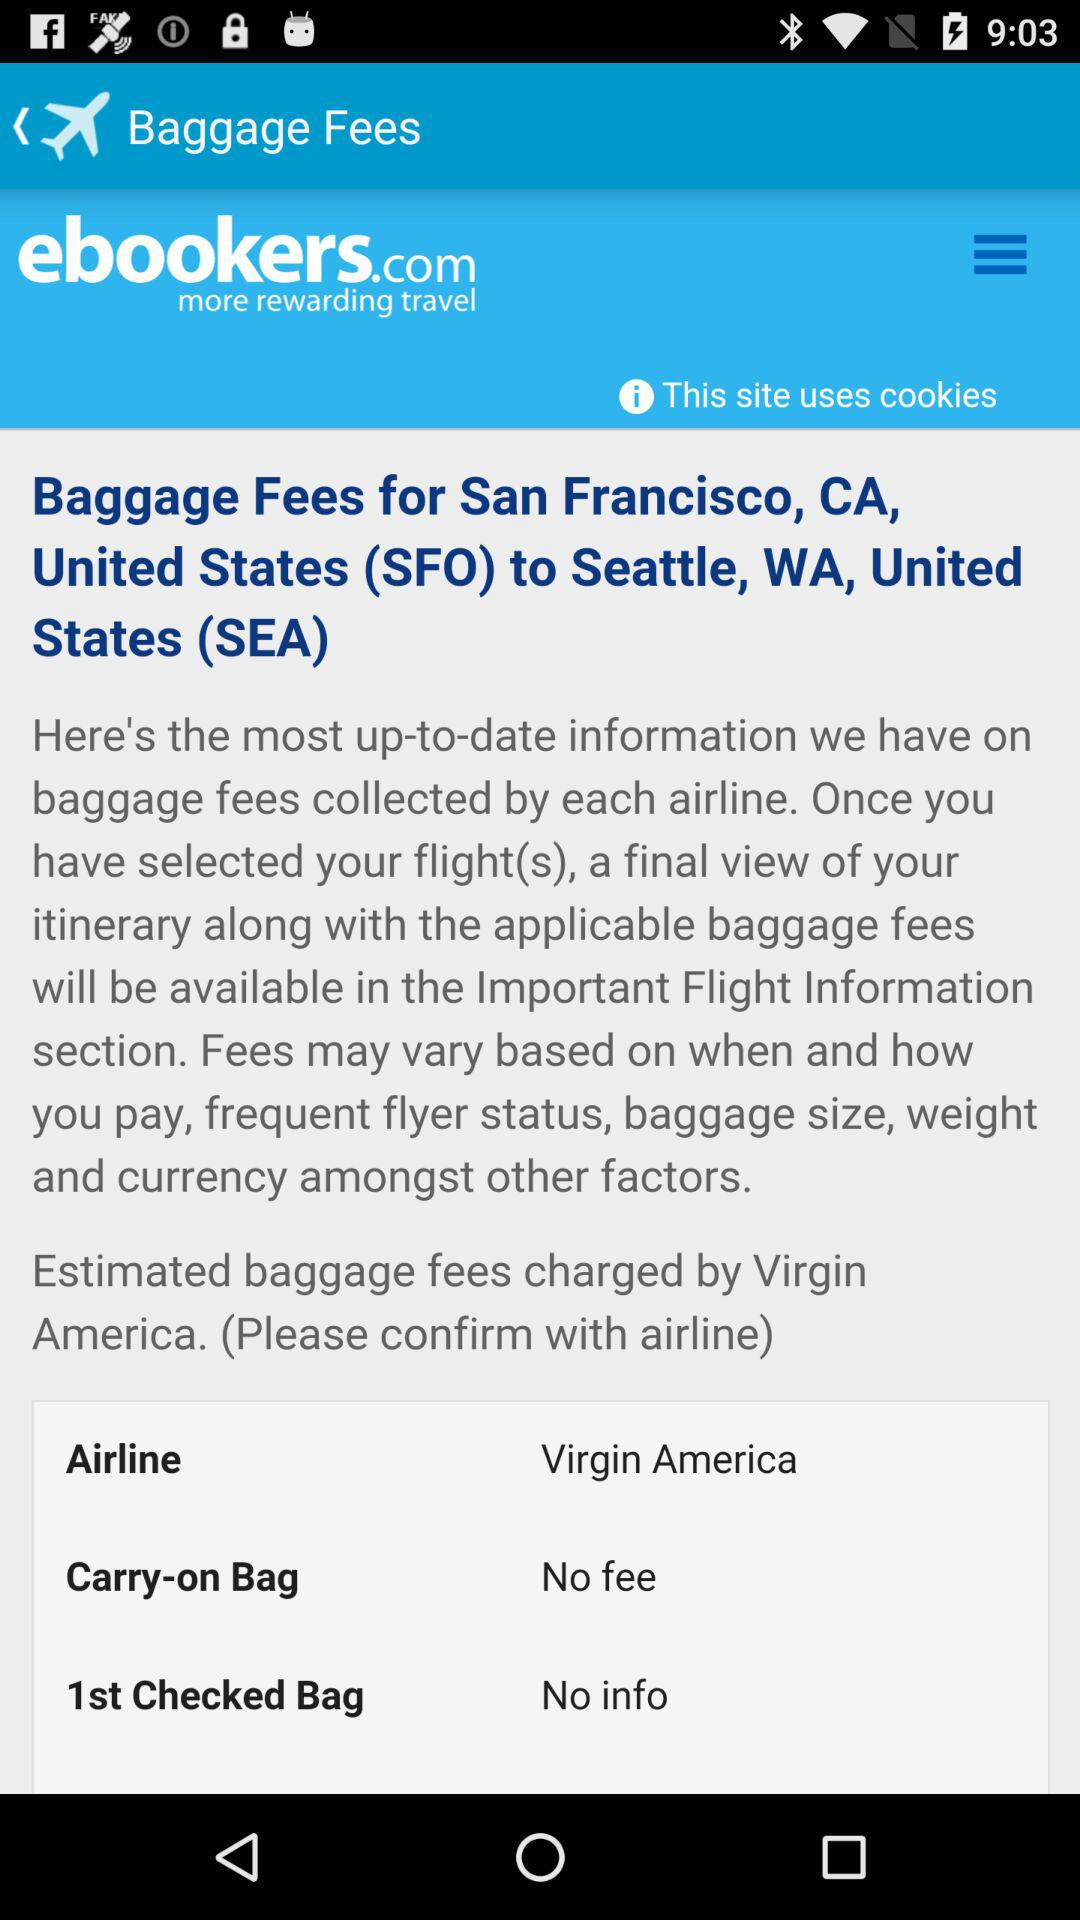What is the airline name? The airline name is "Virgin America". 